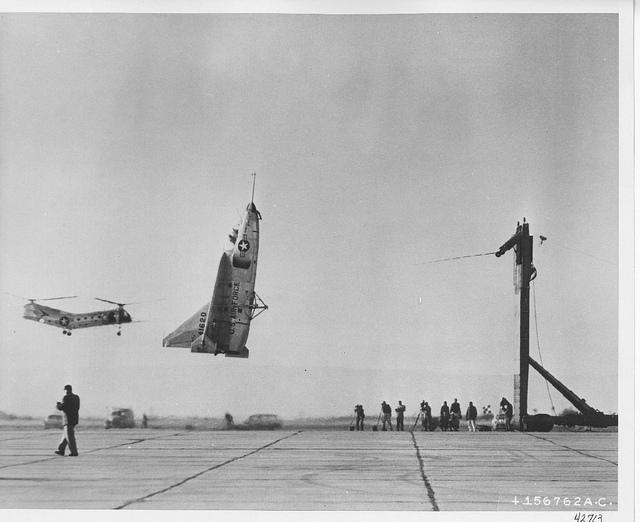Is this rocket really flying?
Write a very short answer. Yes. What is this guy doing?
Be succinct. Walking. What is out of the ordinary?
Concise answer only. Plane. Where are the people?
Write a very short answer. On ground. 